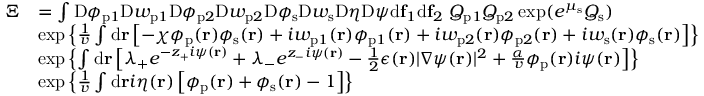Convert formula to latex. <formula><loc_0><loc_0><loc_500><loc_500>\begin{array} { r l } { \Xi } & { = \int D \phi _ { p 1 } D w _ { p 1 } D \phi _ { p 2 } D w _ { p 2 } D \phi _ { s } D w _ { s } D \eta D \psi d f _ { 1 } d f _ { 2 } \ Q _ { p 1 } Q _ { p 2 } \exp ( e ^ { \mu _ { s } } Q _ { s } ) } \\ & { \exp \left \{ \frac { 1 } { v } \int d r \left [ - \chi \phi _ { p } ( r ) \phi _ { s } ( r ) + i w _ { p 1 } ( r ) \phi _ { p 1 } ( r ) + i w _ { p 2 } ( r ) \phi _ { p 2 } ( r ) + i w _ { s } ( r ) \phi _ { s } ( r ) \right ] \right \} } \\ & { \exp \left \{ \int d r \left [ \lambda _ { + } e ^ { - z _ { + } i \psi ( r ) } + \lambda _ { - } e ^ { z _ { - } i \psi ( r ) } - \frac { 1 } { 2 } \epsilon ( r ) | \nabla \psi ( r ) | ^ { 2 } + \frac { \alpha } { v } \phi _ { p } ( r ) i \psi ( r ) \right ] \right \} } \\ & { \exp \left \{ \frac { 1 } { v } \int d r i \eta ( r ) \left [ \phi _ { p } ( r ) + \phi _ { s } ( r ) - 1 \right ] \right \} } \end{array}</formula> 